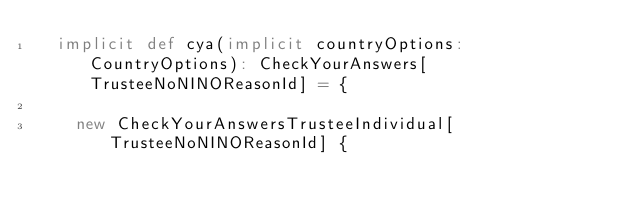<code> <loc_0><loc_0><loc_500><loc_500><_Scala_>  implicit def cya(implicit countryOptions: CountryOptions): CheckYourAnswers[TrusteeNoNINOReasonId] = {

    new CheckYourAnswersTrusteeIndividual[TrusteeNoNINOReasonId] {</code> 